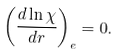<formula> <loc_0><loc_0><loc_500><loc_500>\left ( \frac { d \ln \chi } { d r } \right ) _ { e } = 0 .</formula> 